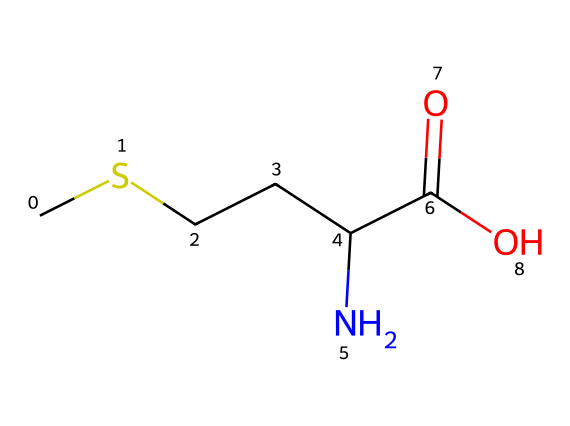What is the name of this chemical? The SMILES representation provided corresponds to methionine, which is a well-known essential amino acid. This can be verified by recognizing the presence of the sulfur atom (S) along with the characteristic amino acid structure (amino group, carboxylic acid, and side chain).
Answer: methionine How many carbon atoms are in methionine? By examining the SMILES representation, we can count the carbon symbols (C). The structure contains five carbon atoms in total, including those in the main chain and the side chain.
Answer: 5 What functional groups are present in this molecule? The SMILES indicates the presence of a carboxylic acid group (-COOH, seen in "C(=O)O") and an amino group (-NH2, seen in "C(N)"). These groups define the molecule as an amino acid.
Answer: carboxylic acid and amino group Is methionine a polar or non-polar molecule? The presence of the polar amino and carboxylic groups typically indicates that the molecule is polar. Additionally, the sulfur atom in the side chain contributes to its overall polarity, making methionine act as a polar amino acid.
Answer: polar What is the significance of the sulfur atom in methionine? The sulfur atom in methionine is crucial as it plays a significant role in sulfur-containing compounds in biological processes. This includes its role in the synthesis of proteins and its function in methylation reactions, which are key for cognitive functions.
Answer: biological significance 